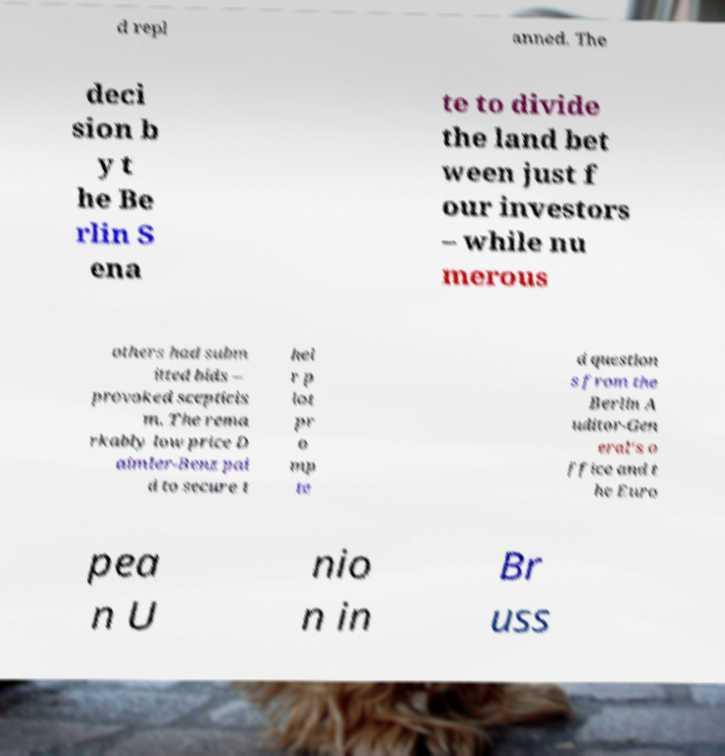I need the written content from this picture converted into text. Can you do that? d repl anned. The deci sion b y t he Be rlin S ena te to divide the land bet ween just f our investors – while nu merous others had subm itted bids – provoked scepticis m. The rema rkably low price D aimler-Benz pai d to secure t hei r p lot pr o mp te d question s from the Berlin A uditor-Gen eral's o ffice and t he Euro pea n U nio n in Br uss 